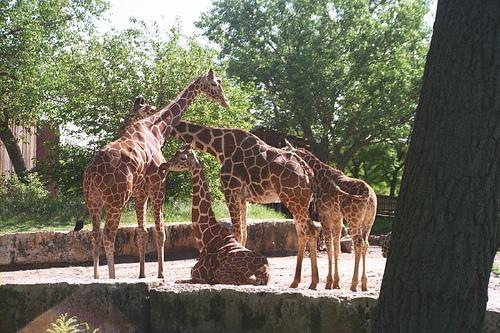How many giraffes are standing in the middle of the stone enclosure? three 